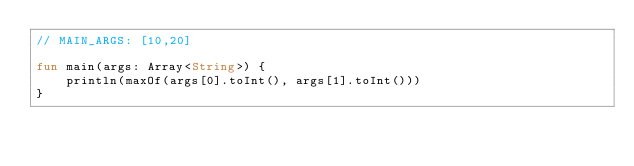Convert code to text. <code><loc_0><loc_0><loc_500><loc_500><_Kotlin_>// MAIN_ARGS: [10,20]

fun main(args: Array<String>) {
    println(maxOf(args[0].toInt(), args[1].toInt()))
}
</code> 